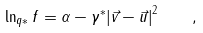<formula> <loc_0><loc_0><loc_500><loc_500>\ln _ { q * } f = \alpha - \gamma ^ { * } { | \vec { v } - \vec { u } | } ^ { 2 } \quad ,</formula> 